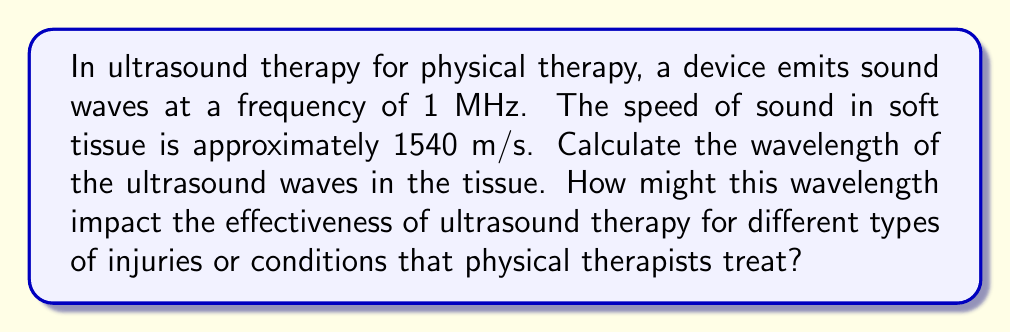Give your solution to this math problem. To solve this problem, we'll use the wave equation that relates wavelength, frequency, and wave speed:

$$v = f \lambda$$

Where:
$v$ = wave speed (m/s)
$f$ = frequency (Hz)
$\lambda$ = wavelength (m)

Given:
$v = 1540$ m/s (speed of sound in soft tissue)
$f = 1$ MHz = $1 \times 10^6$ Hz

Step 1: Rearrange the wave equation to solve for wavelength:
$$\lambda = \frac{v}{f}$$

Step 2: Substitute the known values:
$$\lambda = \frac{1540 \text{ m/s}}{1 \times 10^6 \text{ Hz}}$$

Step 3: Calculate the wavelength:
$$\lambda = 1.54 \times 10^{-3} \text{ m} = 1.54 \text{ mm}$$

The wavelength of the ultrasound waves in soft tissue is 1.54 mm.

Impact on effectiveness:
1. Penetration depth: Shorter wavelengths (higher frequencies) have less penetration but more focused energy. This 1.54 mm wavelength allows for relatively deep penetration while maintaining focus, suitable for various soft tissue injuries.

2. Resolution: The wavelength determines the smallest structures that can be effectively targeted. A 1.54 mm wavelength can interact with small tissue structures, making it effective for treating a range of conditions from muscle strains to tendinitis.

3. Absorption: Different tissues absorb ultrasound energy differently based on wavelength. This wavelength is well-suited for absorption by collagen-rich tissues, making it effective for treating ligament and tendon injuries.

4. Safety: The relatively short wavelength allows for precise targeting, minimizing the risk of heating surrounding tissues, which is crucial for patient safety in physical therapy settings.

Understanding these factors can help policy analysts advocate for appropriate ultrasound therapy equipment and training for physical therapists, ensuring effective and safe treatments for various conditions.
Answer: 1.54 mm 